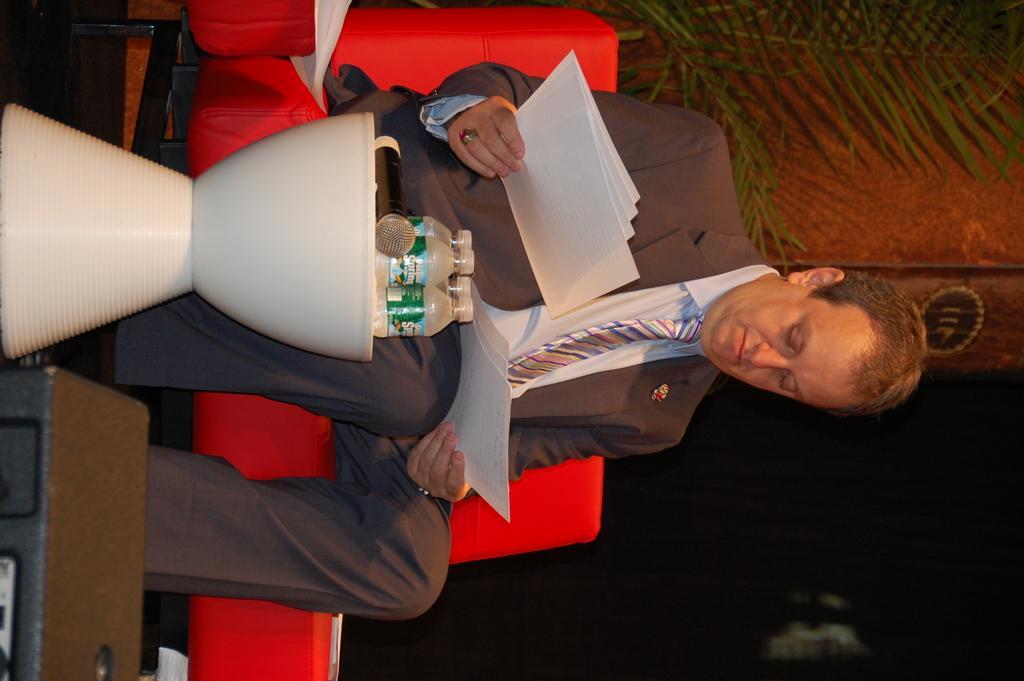Can you describe this image briefly? In this image, we can see a person holding papers and sitting on the couch in front of the table. This table contains bottles and mic. There are leaves in the top right of the image. 